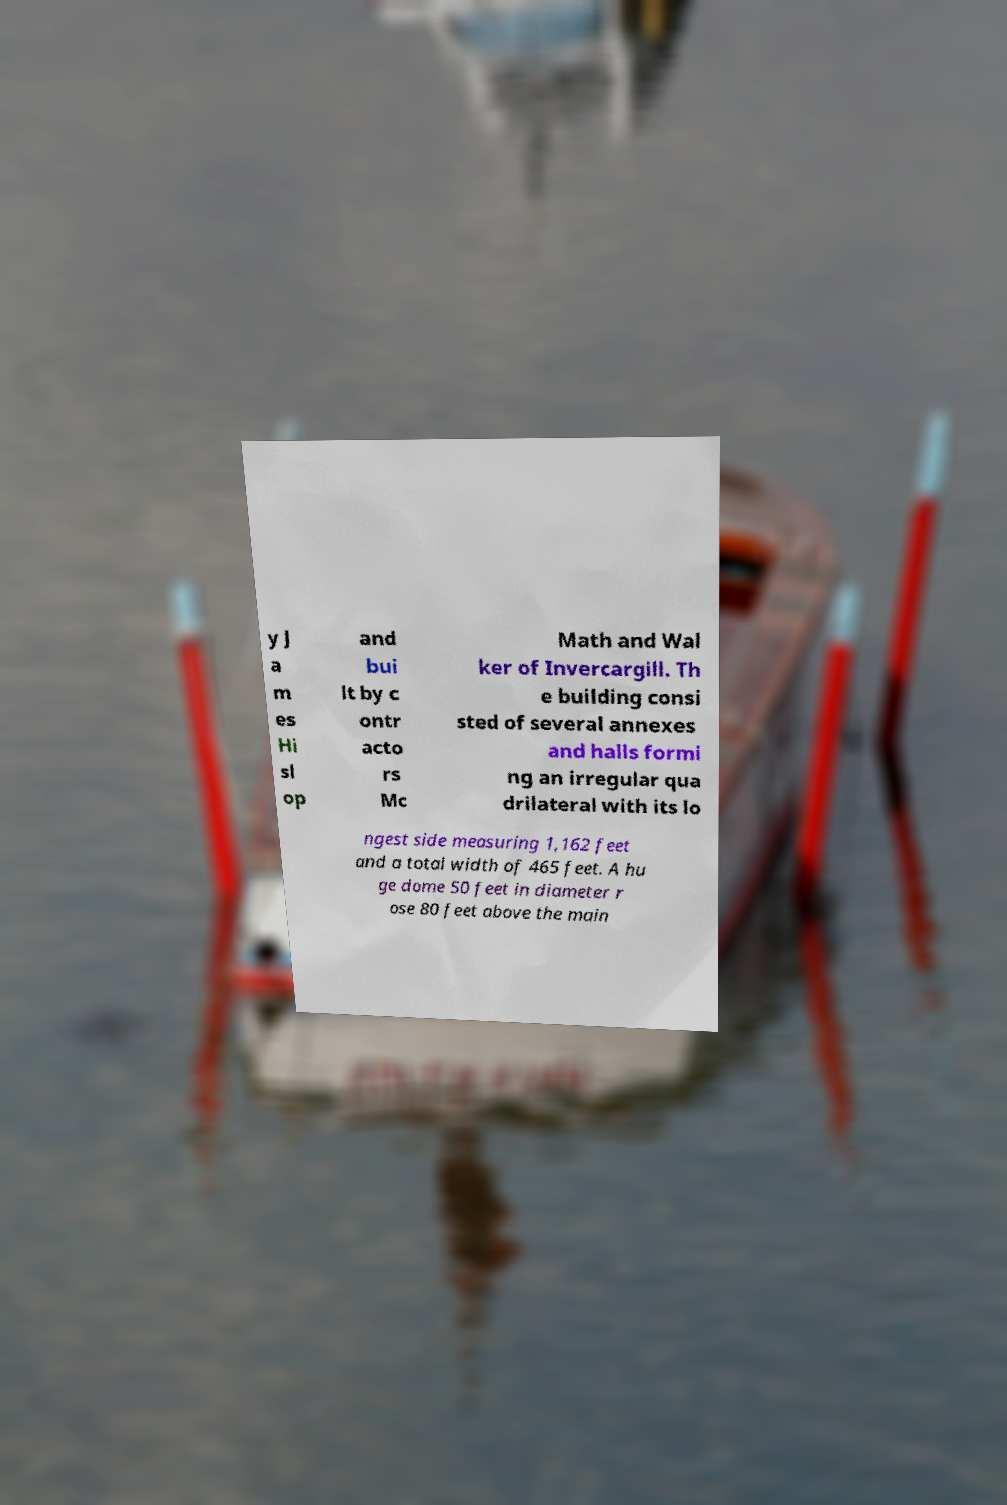I need the written content from this picture converted into text. Can you do that? y J a m es Hi sl op and bui lt by c ontr acto rs Mc Math and Wal ker of Invercargill. Th e building consi sted of several annexes and halls formi ng an irregular qua drilateral with its lo ngest side measuring 1,162 feet and a total width of 465 feet. A hu ge dome 50 feet in diameter r ose 80 feet above the main 